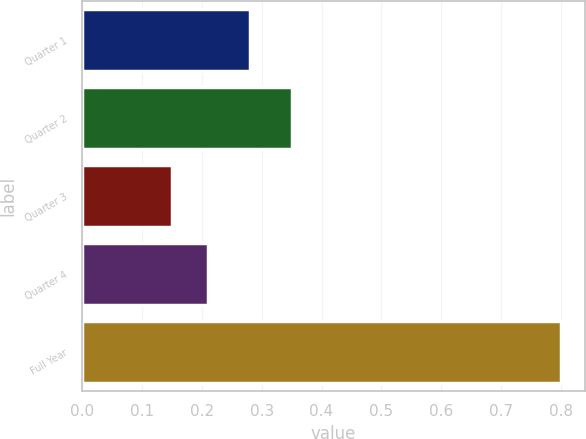Convert chart to OTSL. <chart><loc_0><loc_0><loc_500><loc_500><bar_chart><fcel>Quarter 1<fcel>Quarter 2<fcel>Quarter 3<fcel>Quarter 4<fcel>Full Year<nl><fcel>0.28<fcel>0.35<fcel>0.15<fcel>0.21<fcel>0.8<nl></chart> 